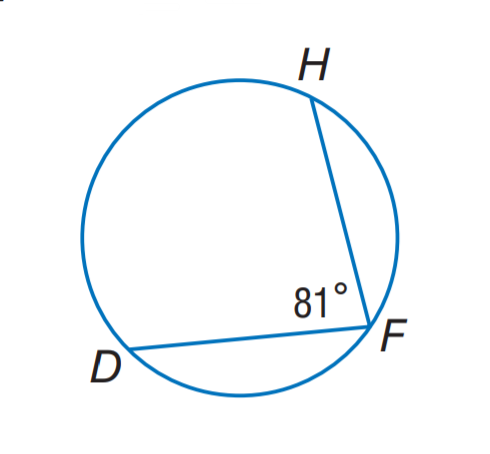Answer the mathemtical geometry problem and directly provide the correct option letter.
Question: Find m \widehat D H.
Choices: A: 81 B: 99 C: 136 D: 162 D 